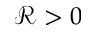<formula> <loc_0><loc_0><loc_500><loc_500>\mathcal { R } > 0</formula> 